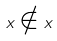Convert formula to latex. <formula><loc_0><loc_0><loc_500><loc_500>x \notin x</formula> 